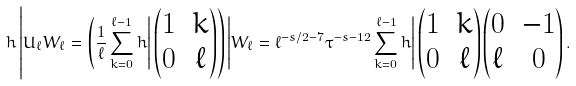Convert formula to latex. <formula><loc_0><loc_0><loc_500><loc_500>h \left | U _ { \ell } W _ { \ell } = \left ( \frac { 1 } { \ell } \sum _ { k = 0 } ^ { \ell - 1 } h \right | \begin{pmatrix} 1 & k \\ 0 & \ell \end{pmatrix} \right ) \left | W _ { \ell } = \ell ^ { - s / 2 - 7 } \tau ^ { - s - 1 2 } \sum _ { k = 0 } ^ { \ell - 1 } h \right | \begin{pmatrix} 1 & k \\ 0 & \ell \end{pmatrix} \begin{pmatrix} 0 & - 1 \\ \ell & 0 \end{pmatrix} .</formula> 